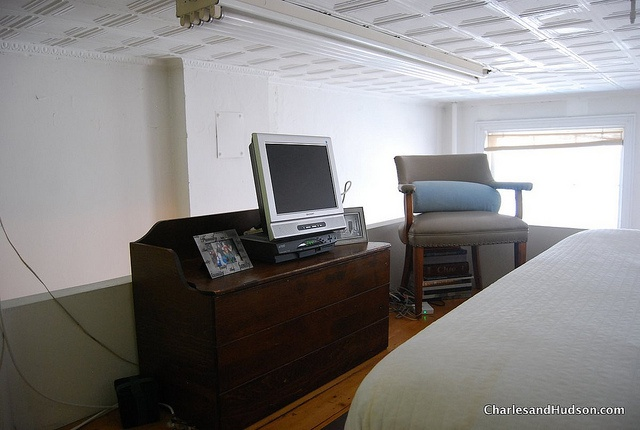Describe the objects in this image and their specific colors. I can see bed in gray and darkgray tones, chair in gray and black tones, tv in gray, black, lightgray, and darkgray tones, book in black and gray tones, and book in gray and black tones in this image. 